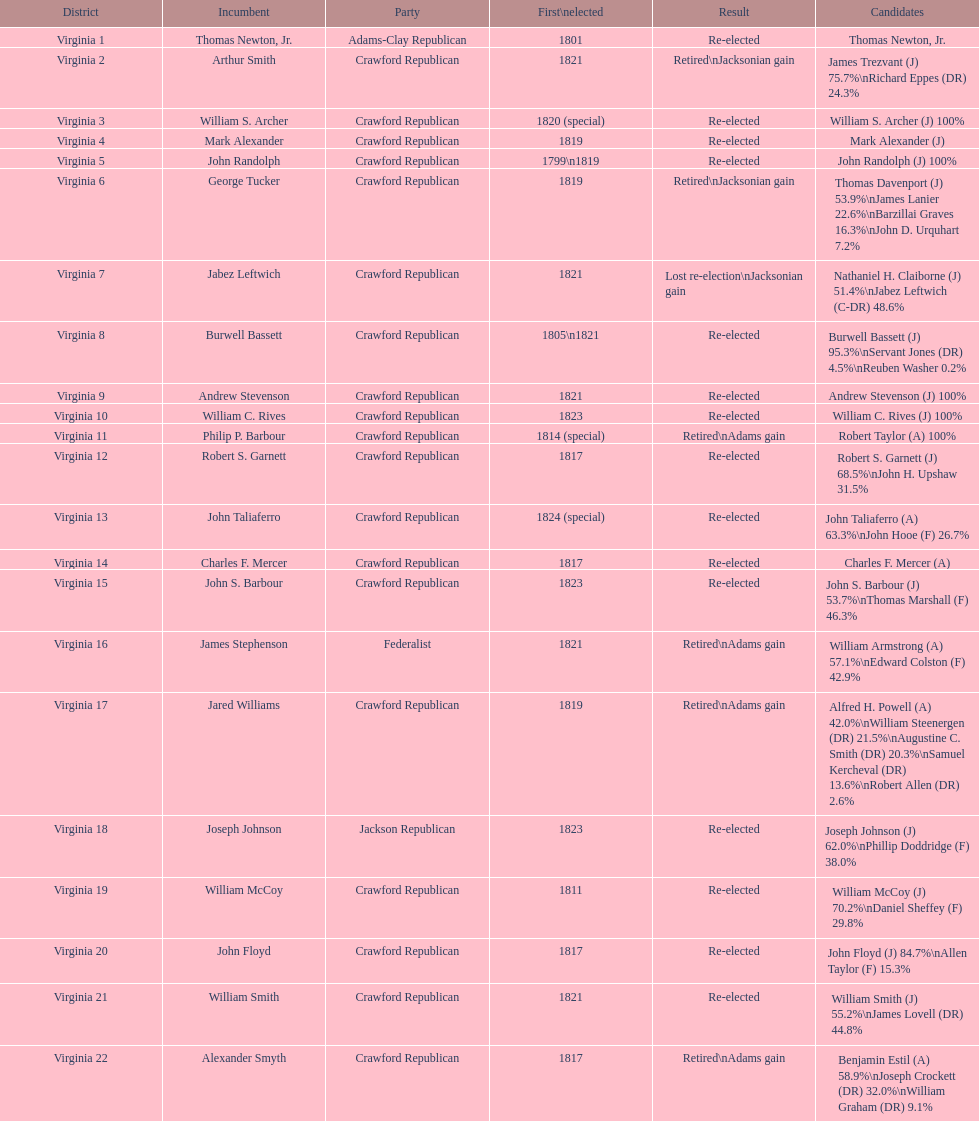Which jacksonian candidates got at least 76% of the vote in their races? Arthur Smith. 